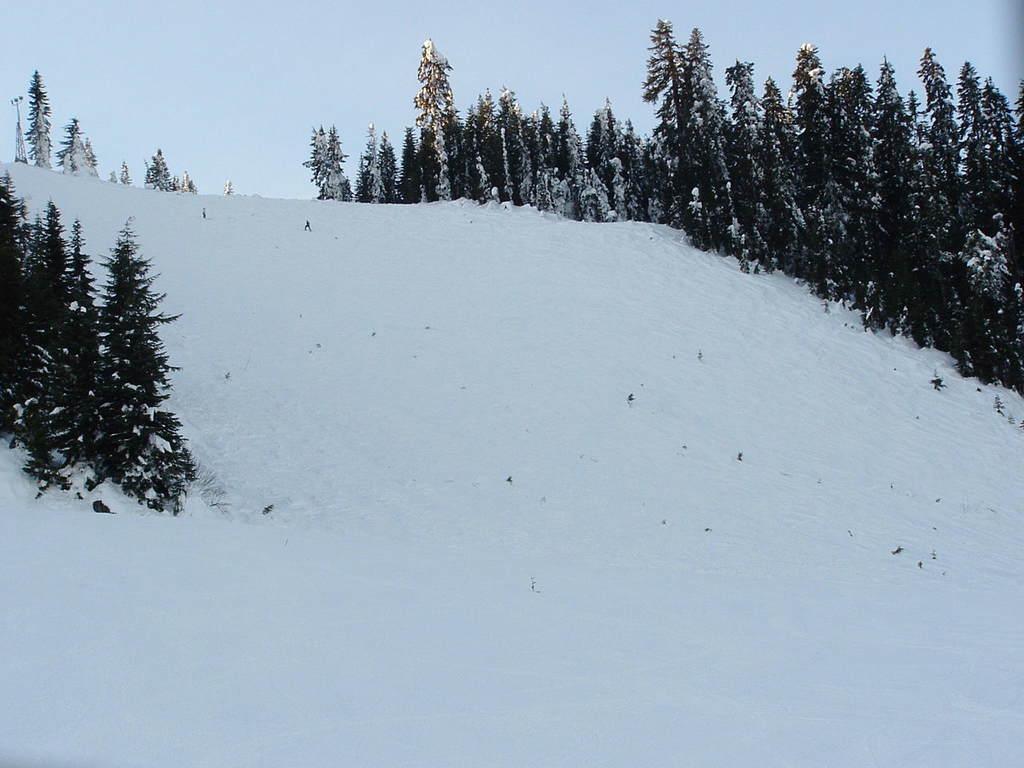Describe this image in one or two sentences. In the image we can see there are many trees, snow and a sky. 